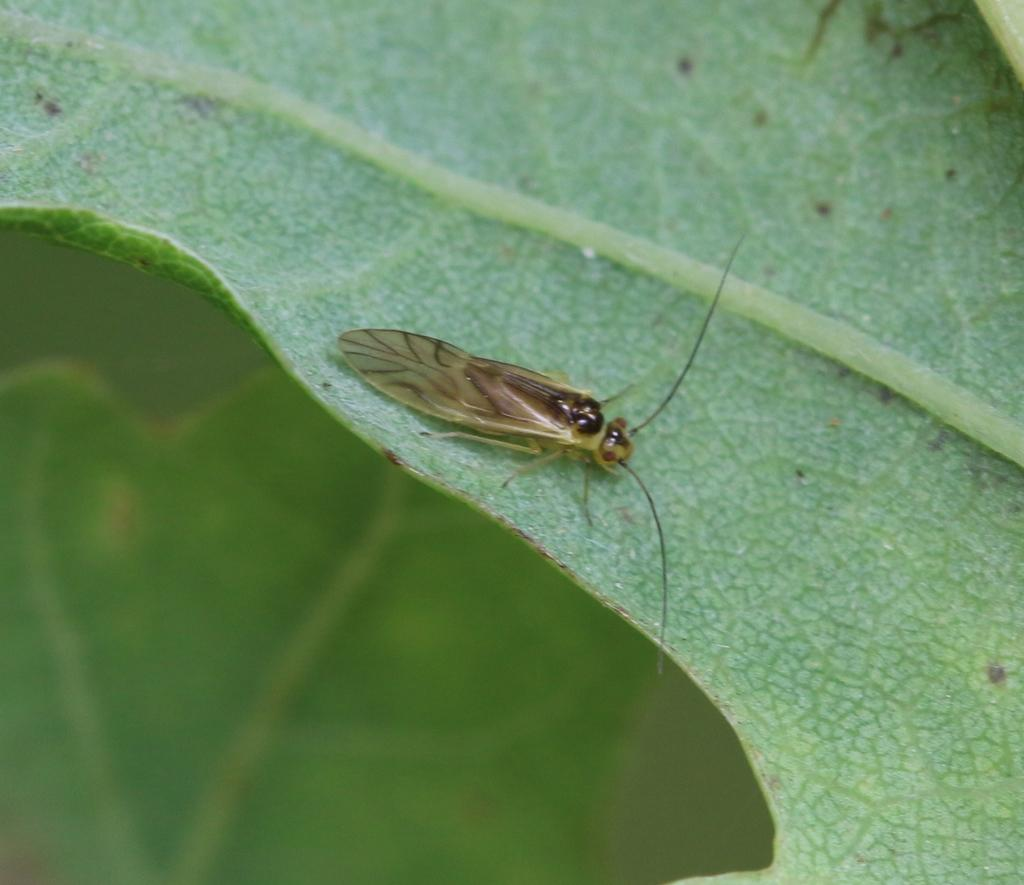What is present on the leaf in the image? There is an insect on a leaf in the image. How much debt does the farmer owe to the bank in the image? There is no farmer or debt mentioned in the image; it features an insect on a leaf. 